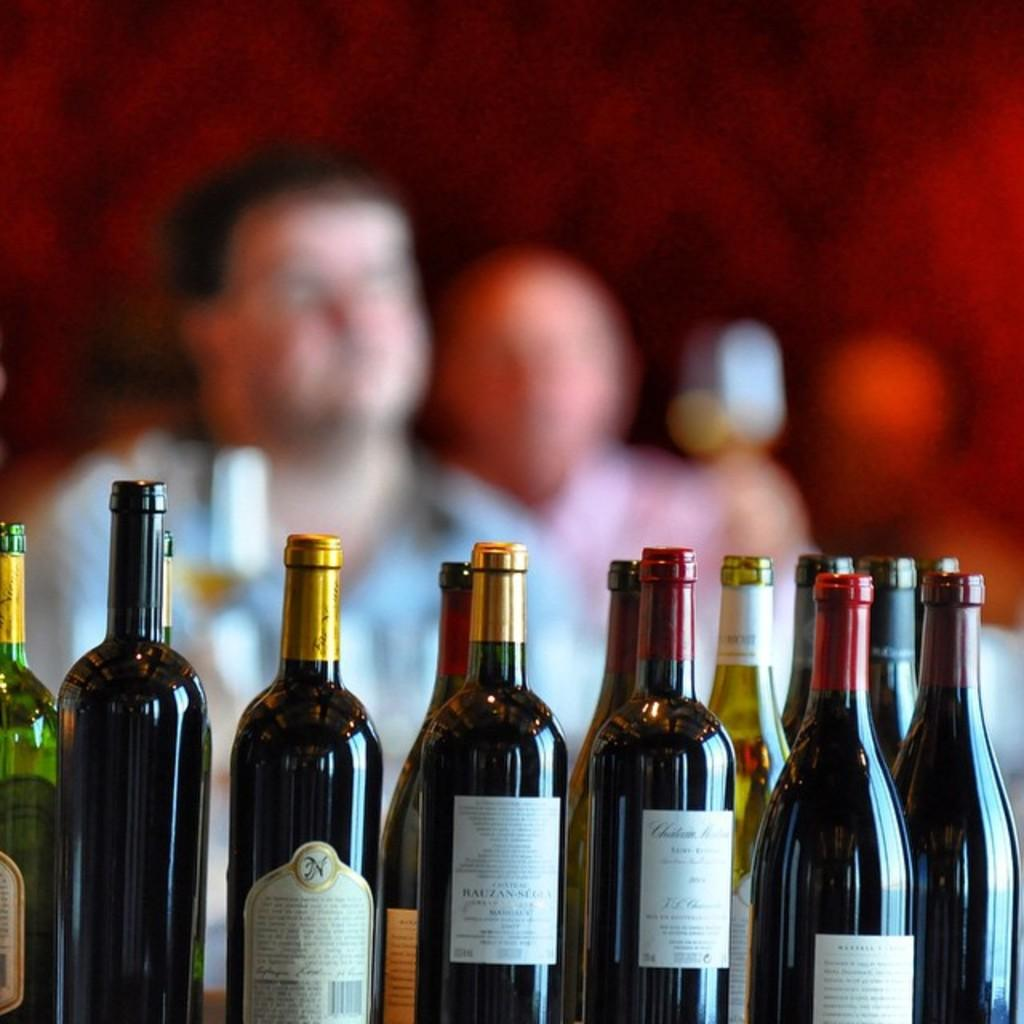What type of beverage containers are present in the image? There are wine bottles in the image. Can you describe the people in the background of the image? Unfortunately, the provided facts do not give any information about the people in the background. What is the primary focus of the image? The primary focus of the image is the wine bottles. What type of suit is the bird wearing in the image? There is no bird present in the image, and therefore no suit can be observed. Is there any eggnog visible in the image? There is no mention of eggnog in the provided facts, so it cannot be determined if it is present in the image. 